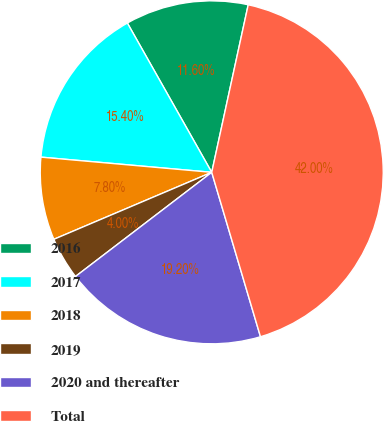<chart> <loc_0><loc_0><loc_500><loc_500><pie_chart><fcel>2016<fcel>2017<fcel>2018<fcel>2019<fcel>2020 and thereafter<fcel>Total<nl><fcel>11.6%<fcel>15.4%<fcel>7.8%<fcel>4.0%<fcel>19.2%<fcel>42.0%<nl></chart> 